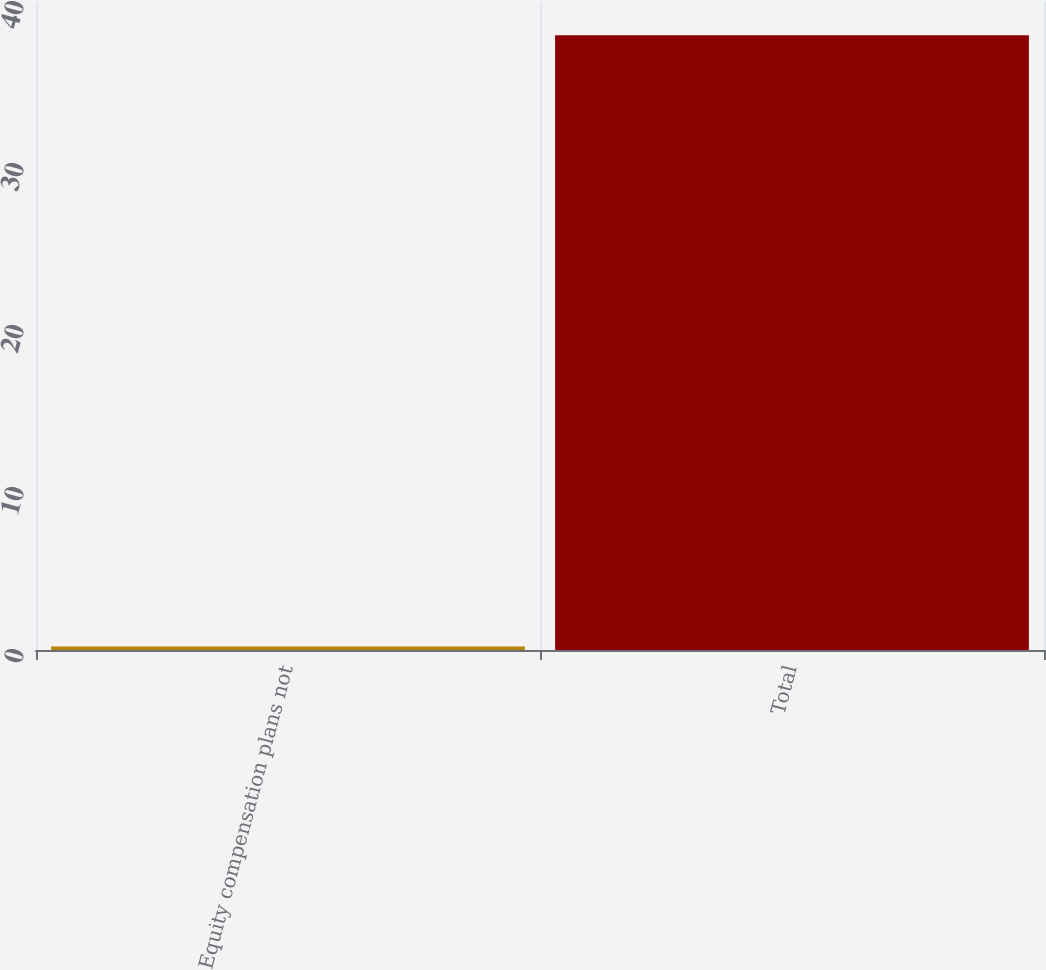Convert chart. <chart><loc_0><loc_0><loc_500><loc_500><bar_chart><fcel>Equity compensation plans not<fcel>Total<nl><fcel>0.21<fcel>37.95<nl></chart> 